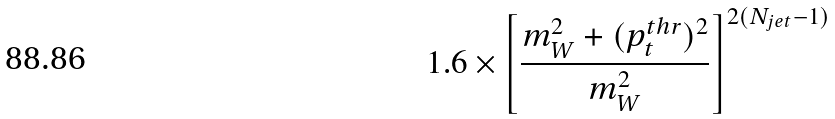<formula> <loc_0><loc_0><loc_500><loc_500>1 . 6 \times \left [ \frac { m _ { W } ^ { 2 } + ( p _ { t } ^ { t h r } ) ^ { 2 } } { m _ { W } ^ { 2 } } \right ] ^ { 2 ( N _ { j e t } - 1 ) }</formula> 